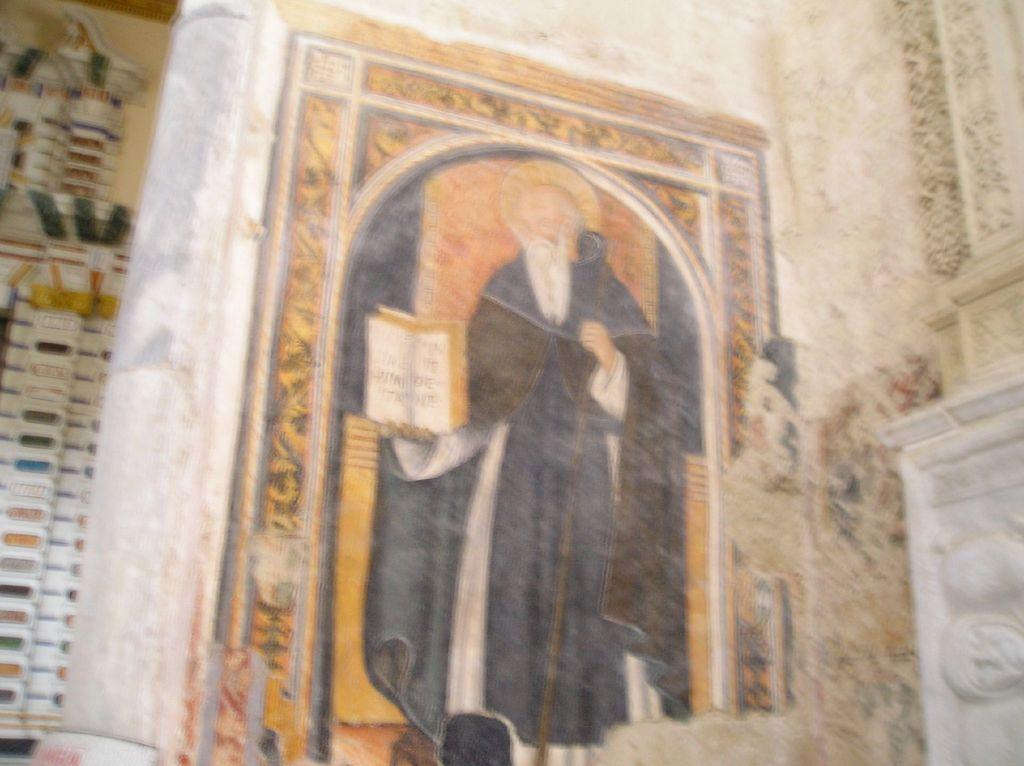What is the main subject of the wall painting in the image? The painting depicts a person holding a book. Can you describe the colorful element to the left of the painting? Unfortunately, the provided facts do not mention any colorful element to the left of the painting. What is the overall theme or style of the wall painting? The overall theme or style of the wall painting cannot be determined from the provided facts. What type of celery is being used as bait in the image? There is no celery or bait present in the image; it features a wall painting of a person holding a book. 